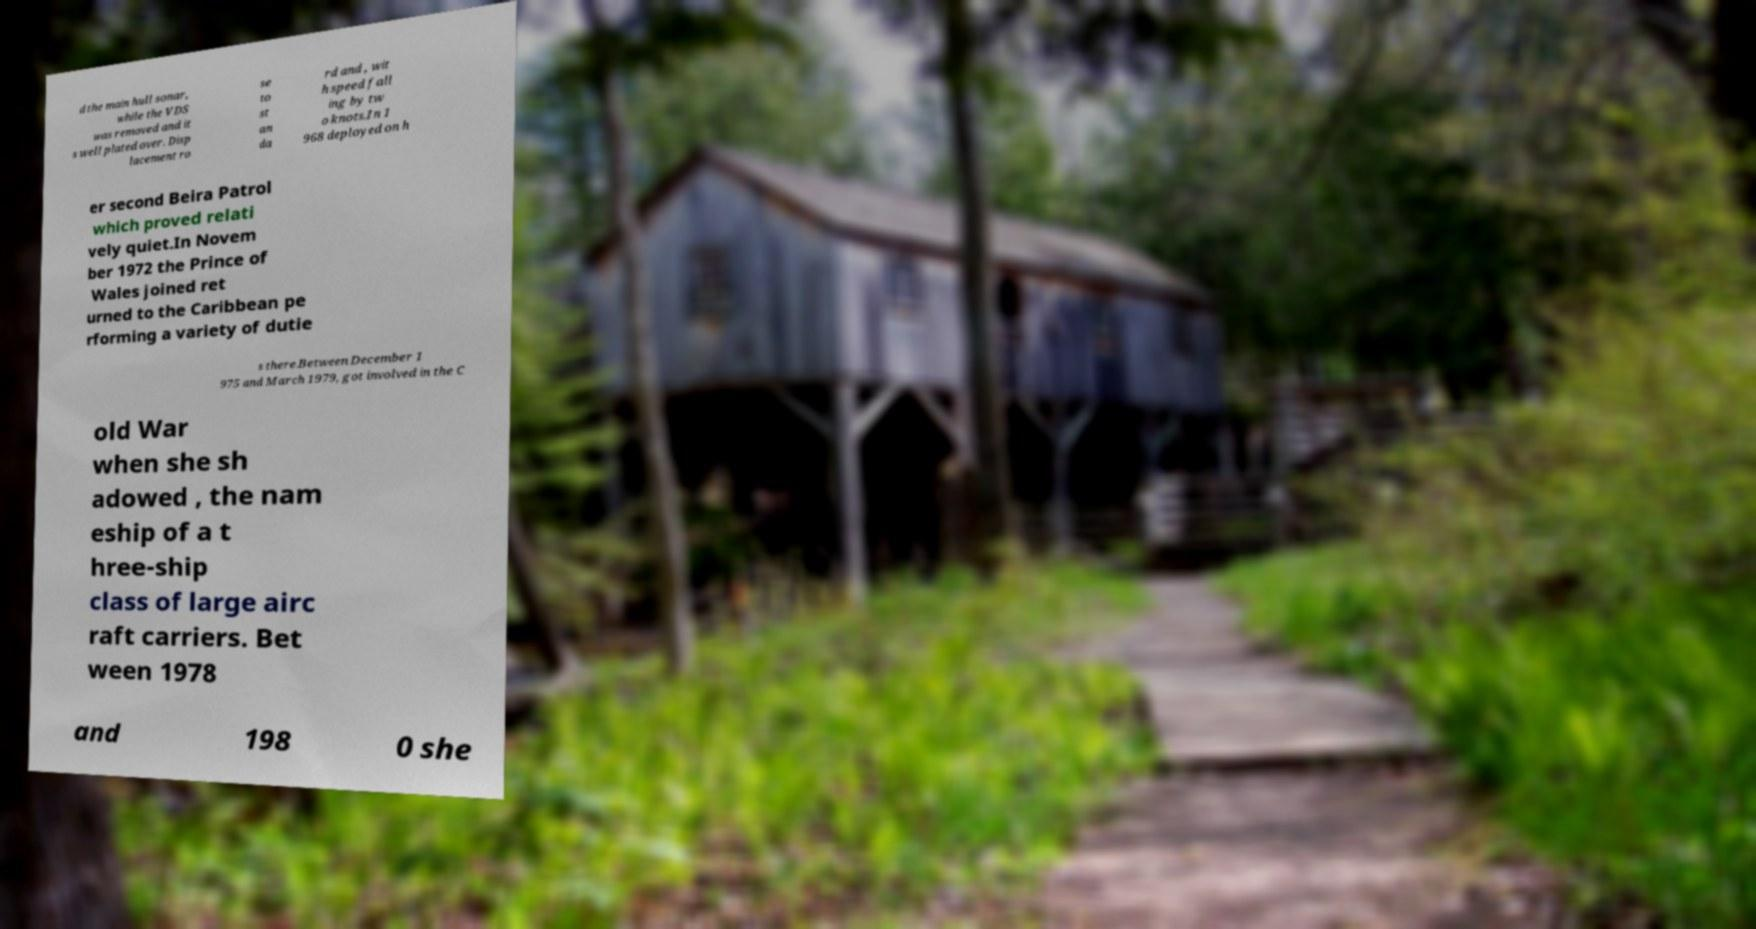There's text embedded in this image that I need extracted. Can you transcribe it verbatim? d the main hull sonar, while the VDS was removed and it s well plated over. Disp lacement ro se to st an da rd and , wit h speed fall ing by tw o knots.In 1 968 deployed on h er second Beira Patrol which proved relati vely quiet.In Novem ber 1972 the Prince of Wales joined ret urned to the Caribbean pe rforming a variety of dutie s there.Between December 1 975 and March 1979, got involved in the C old War when she sh adowed , the nam eship of a t hree-ship class of large airc raft carriers. Bet ween 1978 and 198 0 she 